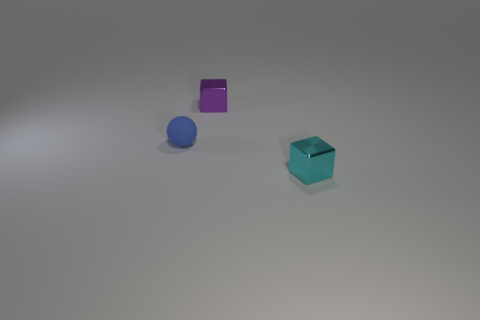What material is the other thing that is the same shape as the cyan thing?
Ensure brevity in your answer.  Metal. What is the color of the tiny object that is both to the left of the tiny cyan object and on the right side of the ball?
Your answer should be compact. Purple. Is there a cyan metallic block behind the tiny block behind the object that is in front of the matte object?
Give a very brief answer. No. How many things are big purple cylinders or tiny metallic objects?
Give a very brief answer. 2. Do the tiny purple block and the small block in front of the matte sphere have the same material?
Your answer should be very brief. Yes. Is there any other thing of the same color as the small matte thing?
Ensure brevity in your answer.  No. What number of objects are either things that are on the left side of the small cyan shiny object or tiny shiny things that are behind the tiny blue ball?
Your answer should be compact. 2. There is a tiny object that is behind the cyan shiny block and in front of the small purple metallic block; what is its shape?
Offer a terse response. Sphere. What number of tiny things are on the right side of the tiny shiny block that is to the left of the cyan metal thing?
Ensure brevity in your answer.  1. Is there anything else that has the same material as the tiny purple object?
Give a very brief answer. Yes. 